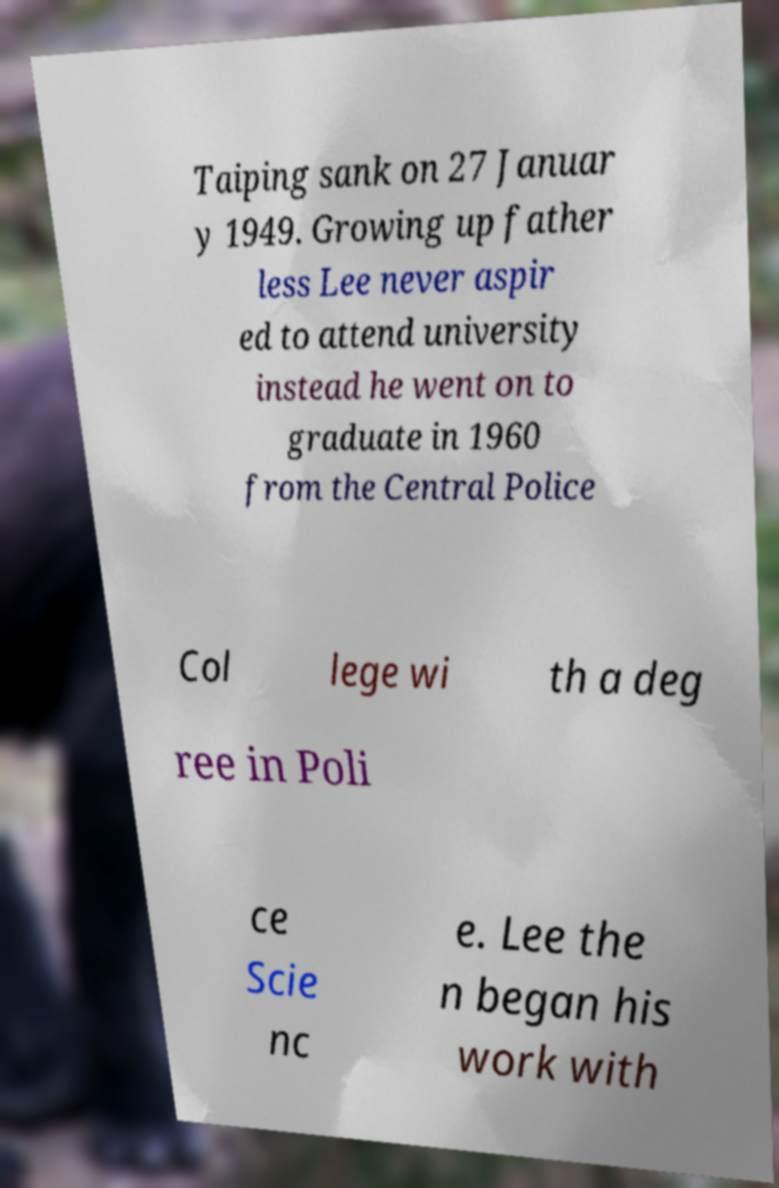Can you accurately transcribe the text from the provided image for me? Taiping sank on 27 Januar y 1949. Growing up father less Lee never aspir ed to attend university instead he went on to graduate in 1960 from the Central Police Col lege wi th a deg ree in Poli ce Scie nc e. Lee the n began his work with 